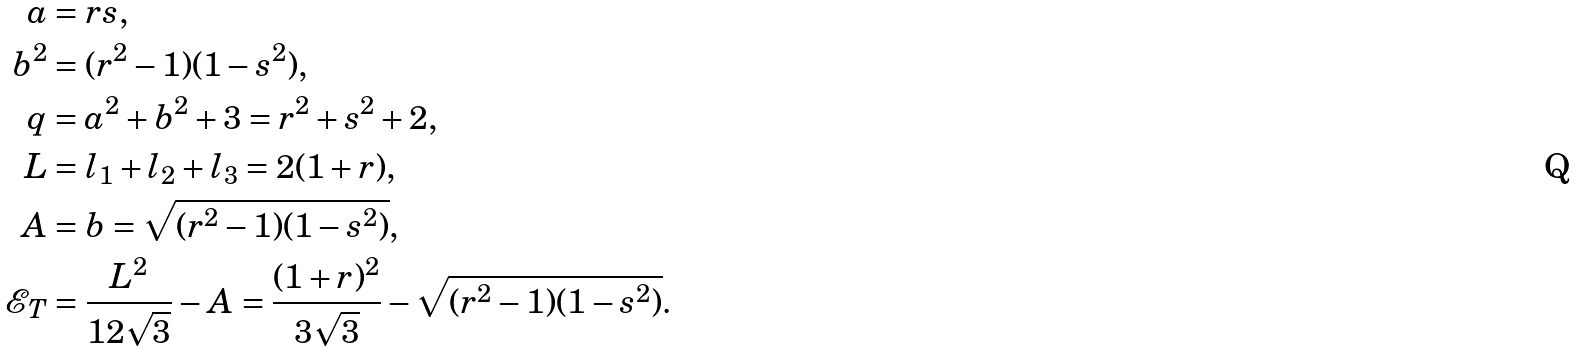<formula> <loc_0><loc_0><loc_500><loc_500>a & = r s , \\ b ^ { 2 } & = ( r ^ { 2 } - 1 ) ( 1 - s ^ { 2 } ) , \\ q & = a ^ { 2 } + b ^ { 2 } + 3 = r ^ { 2 } + s ^ { 2 } + 2 , \\ L & = l _ { 1 } + l _ { 2 } + l _ { 3 } = 2 ( 1 + r ) , \\ A & = b = \sqrt { ( r ^ { 2 } - 1 ) ( 1 - s ^ { 2 } ) } , \\ { \mathcal { E } } _ { T } & = \frac { L ^ { 2 } } { 1 2 \sqrt { 3 } } - A = \frac { ( 1 + r ) ^ { 2 } } { 3 \sqrt { 3 } } - \sqrt { ( r ^ { 2 } - 1 ) ( 1 - s ^ { 2 } ) } .</formula> 